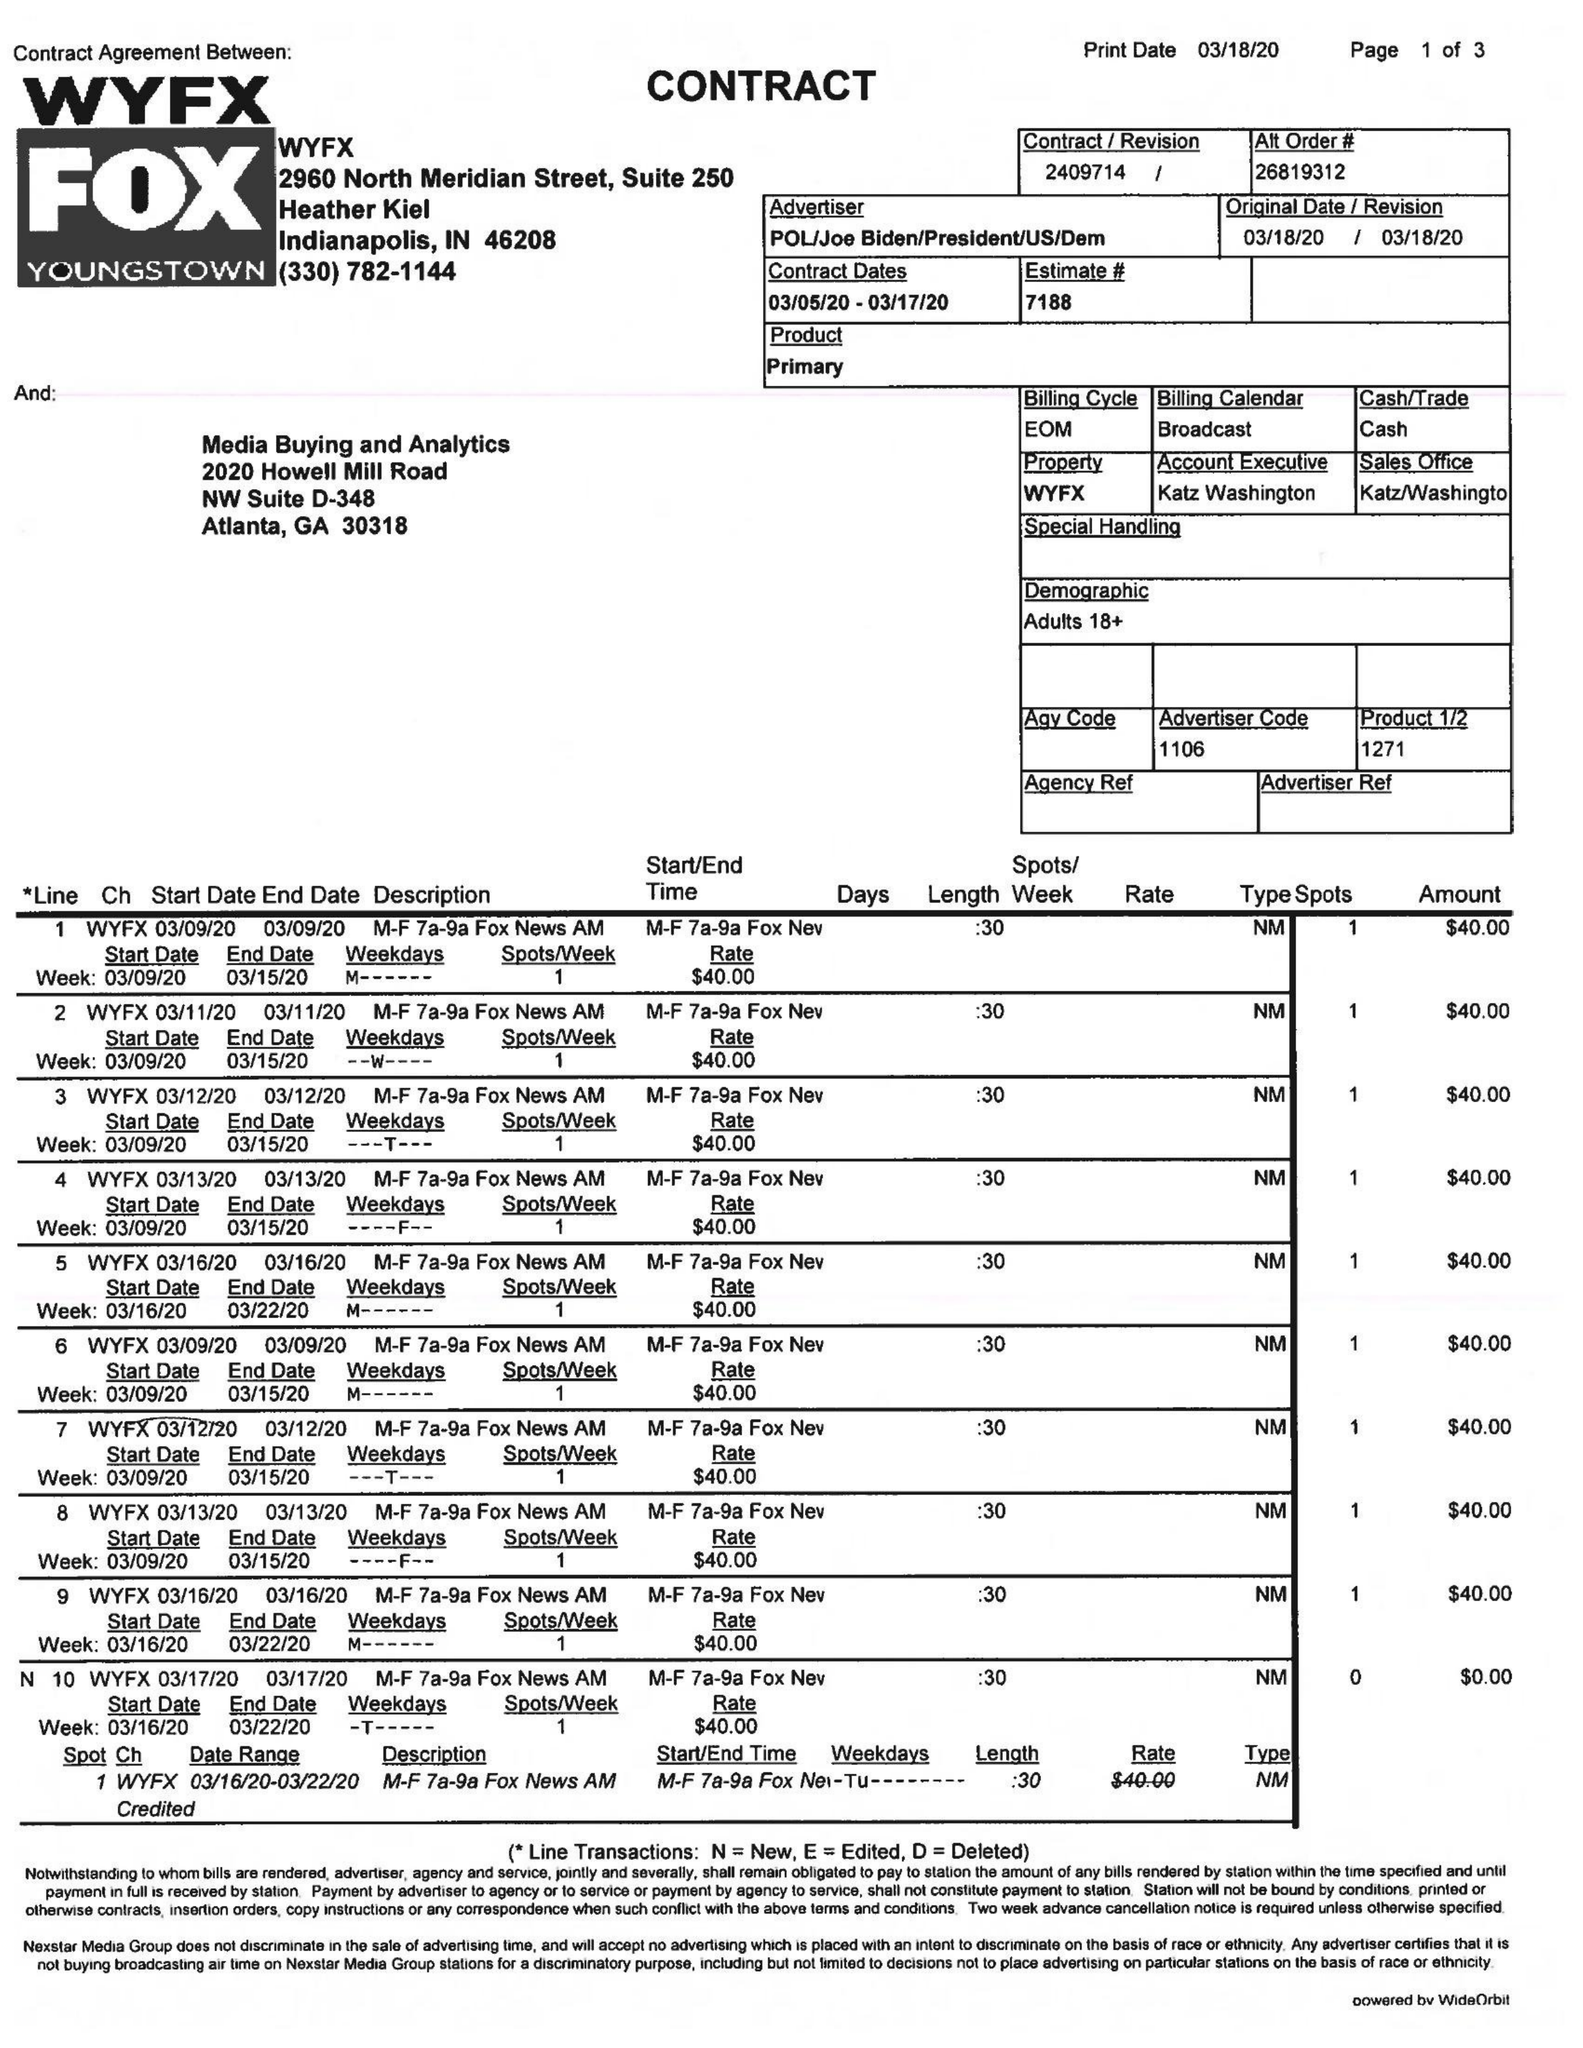What is the value for the gross_amount?
Answer the question using a single word or phrase. 1915.00 